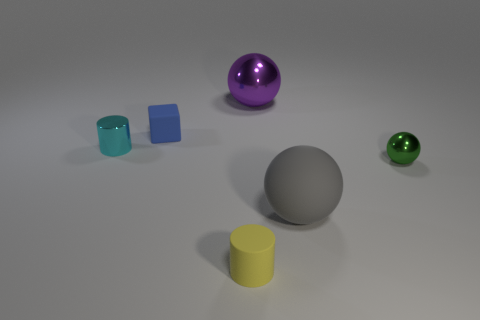Add 1 tiny gray matte spheres. How many objects exist? 7 Subtract all cylinders. How many objects are left? 4 Add 3 small cyan metal objects. How many small cyan metal objects are left? 4 Add 1 big brown rubber objects. How many big brown rubber objects exist? 1 Subtract 0 gray cylinders. How many objects are left? 6 Subtract all gray shiny balls. Subtract all purple shiny objects. How many objects are left? 5 